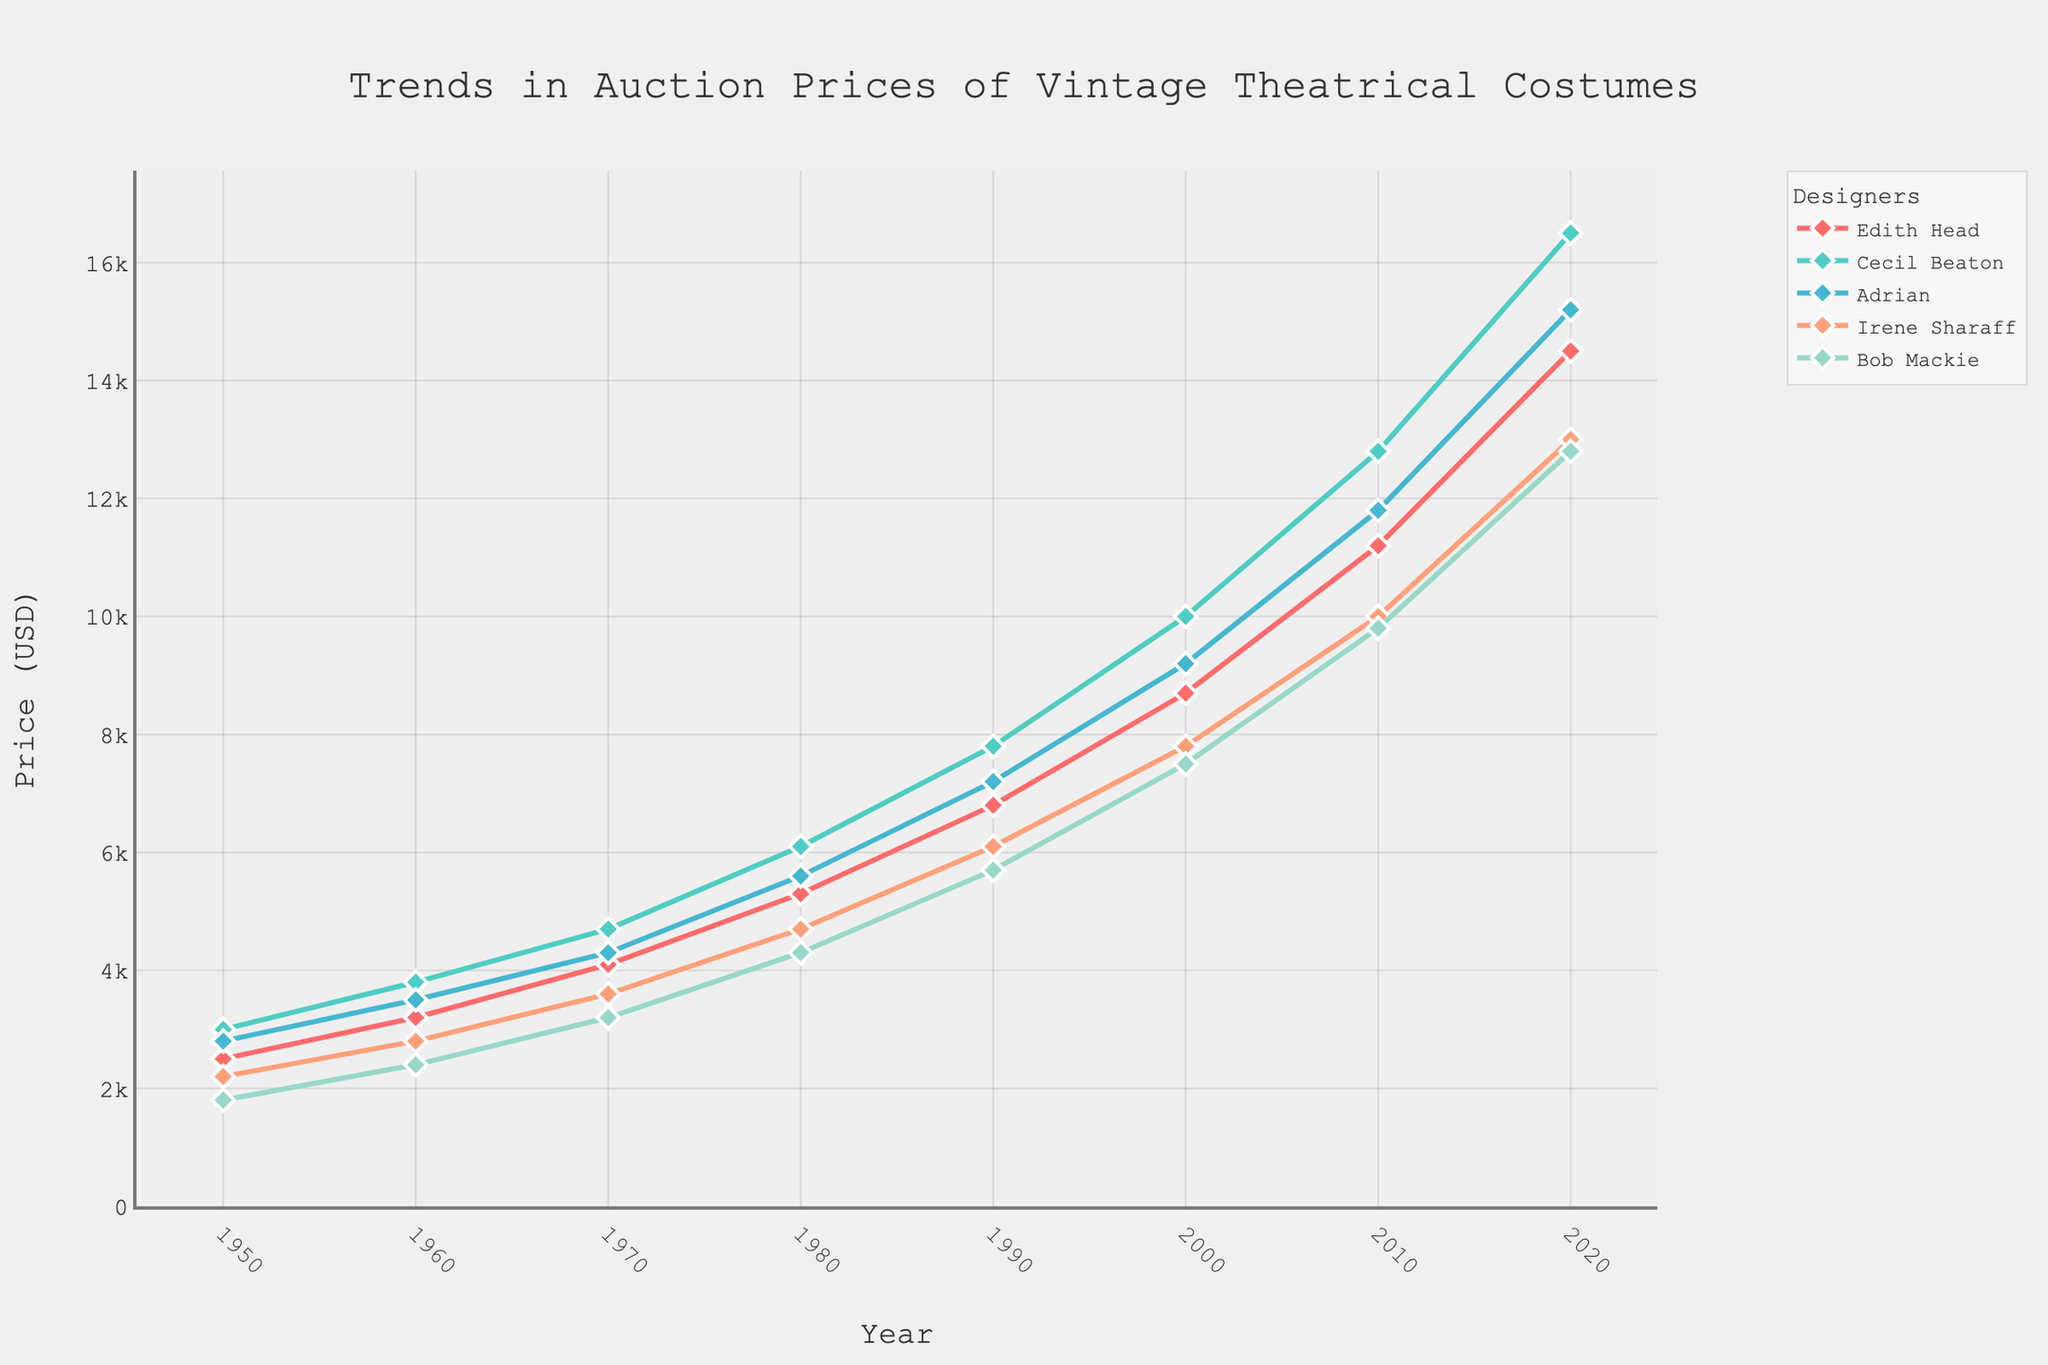What's the trend in the auction prices of costumes designed by Edith Head from 1950 to 2020? The trend can be observed by following the line for Edith Head from 1950 to 2020. The prices start at $2500 in 1950 and steadily increase to $14500 by 2020. Therefore, the auction prices for Edith Head's costumes have been increasing over the years.
Answer: Increasing Which designer's costumes had the highest auction price in 2020? To determine this, we look at the data points for 2020 across all designers. Cecil Beaton's costumes have the highest auction price at $16500.
Answer: Cecil Beaton Between 1960 and 1980, whose costumes saw the largest absolute increase in auction price? By comparing data for each designer from 1960 to 1980, we calculate the absolute increase: Edith Head (5300-3200 = 2100), Cecil Beaton (6100-3800 = 2300), Adrian (5600-3500 = 2100), Irene Sharaff (4700-2800 = 1900), Bob Mackie (4300-2400 = 1900). The largest increase was for Cecil Beaton, with an increase of 2300.
Answer: Cecil Beaton What is the average auction price of Adrian's costumes over the eight time points provided? The auction prices of Adrian's costumes are: 2800, 3500, 4300, 5600, 7200, 9200, 11800, 15200. The sum of these prices is 59600. Dividing this sum by 8 gives us the average auction price: 59600/8 = 7450.
Answer: 7450 How does the general price trend for Bob Mackie's costumes compare to that of Irene Sharaff's costumes? Both lines for Bob Mackie and Irene Sharaff show an upward trend from 1950 to 2020. However, Irene Sharaff's prices started higher but became nearly parallel to Bob Mackie's prices post-2000. Both exhibit similar upward trends but started at different values.
Answer: Similar upward trends In which decade did Edith Head's costumes see the steepest price increase? Looking at the line graph for Edith Head, the steepest increase is observed between 2000 and 2010, where the prices rose from $8700 to $11200, an increase of $2500.
Answer: 2000-2010 If you combine the prices of Adrian and Irene Sharaff's costumes in 1990, what is the total? The prices of Adrian and Irene Sharaff's costumes in 1990 are $7200 and $6100, respectively. Adding them gives a total of 7200 + 6100 = 13300.
Answer: 13300 Which designer had the least variability in auction price increases over the years? Observing the lines, Irene Sharaff's line is the most steady and consistent, suggesting the least variability. The lines for other designers show sharper increases and decreases at different points.
Answer: Irene Sharaff Between 2000 and 2020, which designer's costumes had the greatest percentage increase in auction price? The percentage increase from 2000 to 2020 is calculated as ((price in 2020 - price in 2000) / price in 2000) * 100. For each designer:
  - Edith Head: ((14500 - 8700) / 8700) * 100 ≈ 66.67%
  - Cecil Beaton: ((16500 - 10000) / 10000) * 100 ≈ 65%
  - Adrian: ((15200 - 9200) / 9200) * 100 ≈ 65.22%
  - Irene Sharaff: ((13000 - 7800) / 7800) * 100 ≈ 66.67%
  - Bob Mackie: ((12800 - 7500) / 7500) * 100 ≈ 70.67%
Bob Mackie's costumes had the greatest percentage increase.
Answer: Bob Mackie 